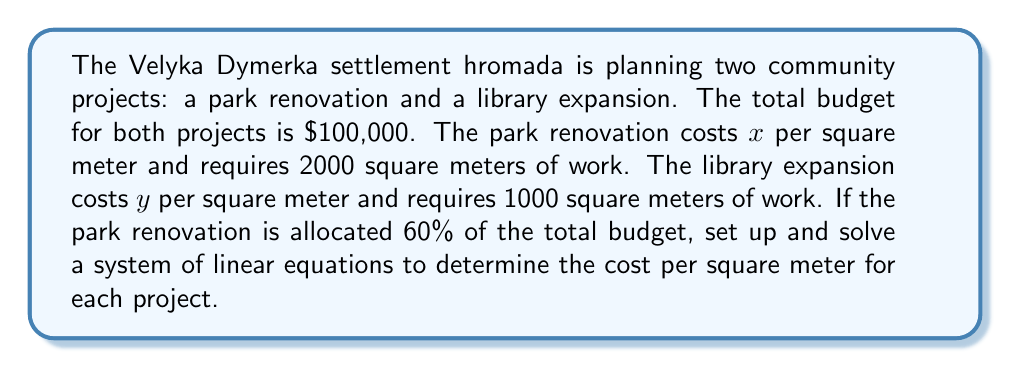Could you help me with this problem? Let's approach this step-by-step:

1) First, let's define our variables:
   $x$ = cost per square meter for park renovation
   $y$ = cost per square meter for library expansion

2) Now, we can set up two equations based on the given information:

   Equation 1: Total budget equation
   $2000x + 1000y = 100,000$

   Equation 2: Park renovation budget (60% of total)
   $2000x = 0.6(100,000) = 60,000$

3) From Equation 2, we can easily solve for $x$:
   $2000x = 60,000$
   $x = 30$

4) Now that we know $x$, we can substitute it into Equation 1:
   $2000(30) + 1000y = 100,000$
   $60,000 + 1000y = 100,000$

5) Solving for $y$:
   $1000y = 100,000 - 60,000 = 40,000$
   $y = 40$

6) To verify, let's check if these values satisfy both equations:
   Equation 1: $2000(30) + 1000(40) = 60,000 + 40,000 = 100,000$ ✓
   Equation 2: $2000(30) = 60,000$ ✓

Therefore, the park renovation costs $30 per square meter, and the library expansion costs $40 per square meter.
Answer: $x = 30, y = 40$ 